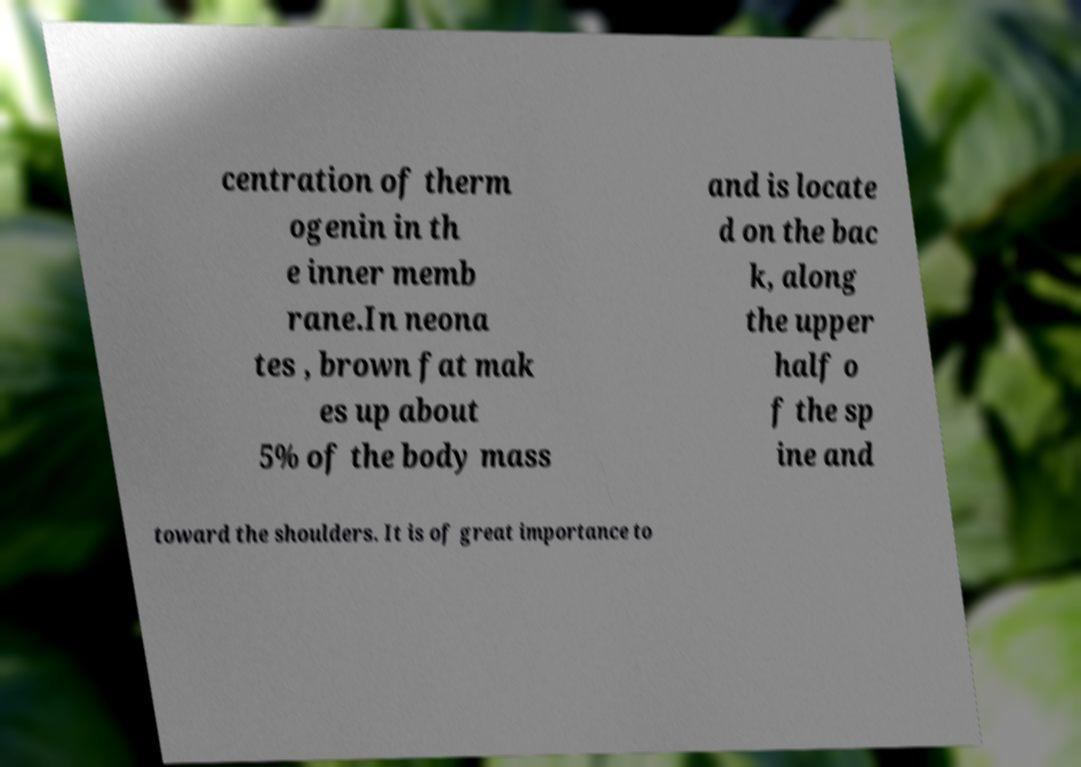Please read and relay the text visible in this image. What does it say? centration of therm ogenin in th e inner memb rane.In neona tes , brown fat mak es up about 5% of the body mass and is locate d on the bac k, along the upper half o f the sp ine and toward the shoulders. It is of great importance to 